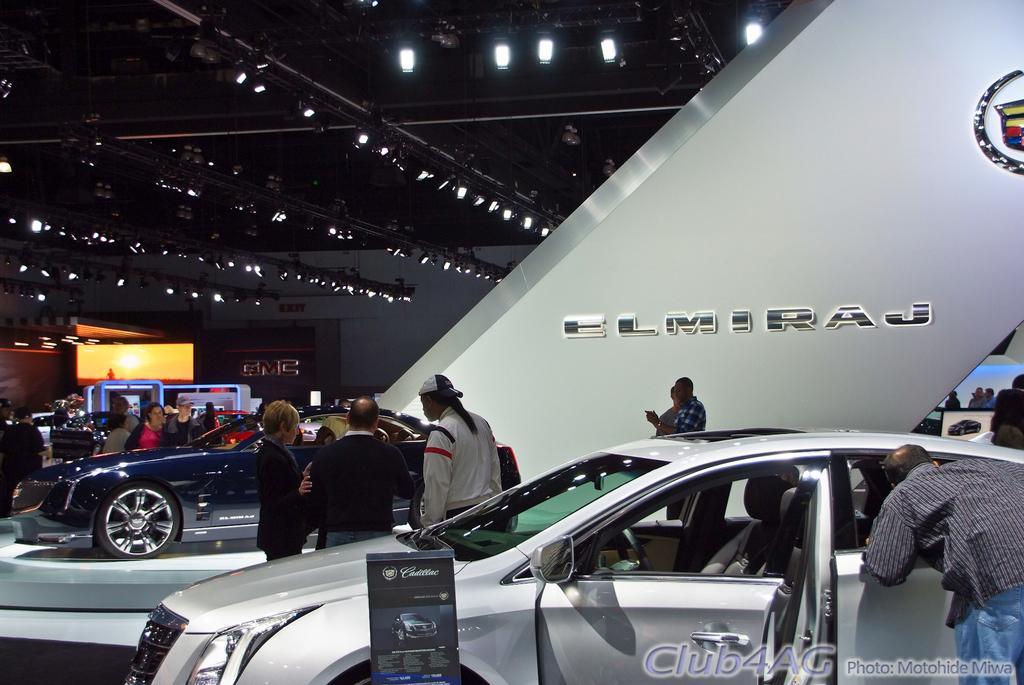Could you give a brief overview of what you see in this image? This picture seems to be clicked inside the hall. In the center we can see the group of cars parked on the ground and we can see the group of persons. At the top there is a roof and we can see the metal rods, lights. In the background we can see the wall and we can see the text. In the center we can see an object on which we can see the text and a picture of a car. In the bottom right corner we can see the watermark on the image and we can see some other objects. 